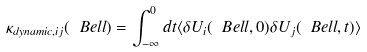Convert formula to latex. <formula><loc_0><loc_0><loc_500><loc_500>\kappa _ { d y n a m i c , i j } ( \ B e l l ) = \int _ { - \infty } ^ { 0 } d t \langle \delta U _ { i } ( \ B e l l , 0 ) \delta U _ { j } ( \ B e l l , t ) \rangle</formula> 